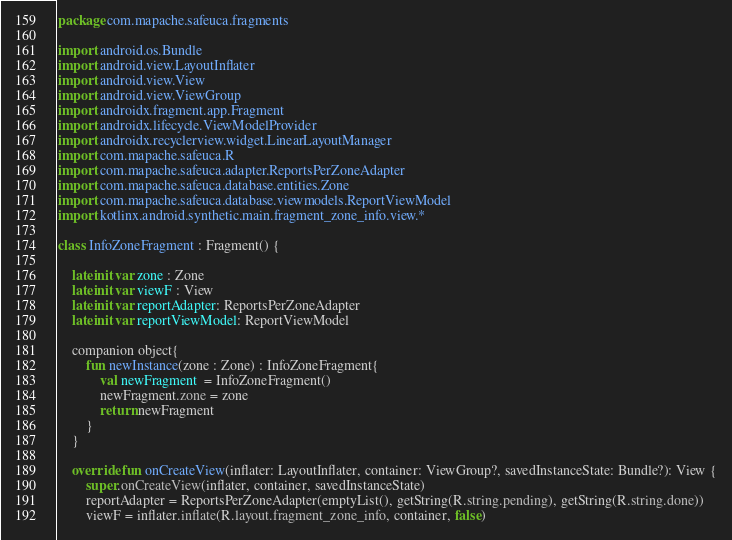<code> <loc_0><loc_0><loc_500><loc_500><_Kotlin_>package com.mapache.safeuca.fragments

import android.os.Bundle
import android.view.LayoutInflater
import android.view.View
import android.view.ViewGroup
import androidx.fragment.app.Fragment
import androidx.lifecycle.ViewModelProvider
import androidx.recyclerview.widget.LinearLayoutManager
import com.mapache.safeuca.R
import com.mapache.safeuca.adapter.ReportsPerZoneAdapter
import com.mapache.safeuca.database.entities.Zone
import com.mapache.safeuca.database.viewmodels.ReportViewModel
import kotlinx.android.synthetic.main.fragment_zone_info.view.*

class InfoZoneFragment : Fragment() {

    lateinit var zone : Zone
    lateinit var viewF : View
    lateinit var reportAdapter: ReportsPerZoneAdapter
    lateinit var reportViewModel: ReportViewModel

    companion object{
        fun newInstance(zone : Zone) : InfoZoneFragment{
            val newFragment  = InfoZoneFragment()
            newFragment.zone = zone
            return newFragment
        }
    }

    override fun onCreateView(inflater: LayoutInflater, container: ViewGroup?, savedInstanceState: Bundle?): View {
        super.onCreateView(inflater, container, savedInstanceState)
        reportAdapter = ReportsPerZoneAdapter(emptyList(), getString(R.string.pending), getString(R.string.done))
        viewF = inflater.inflate(R.layout.fragment_zone_info, container, false)</code> 